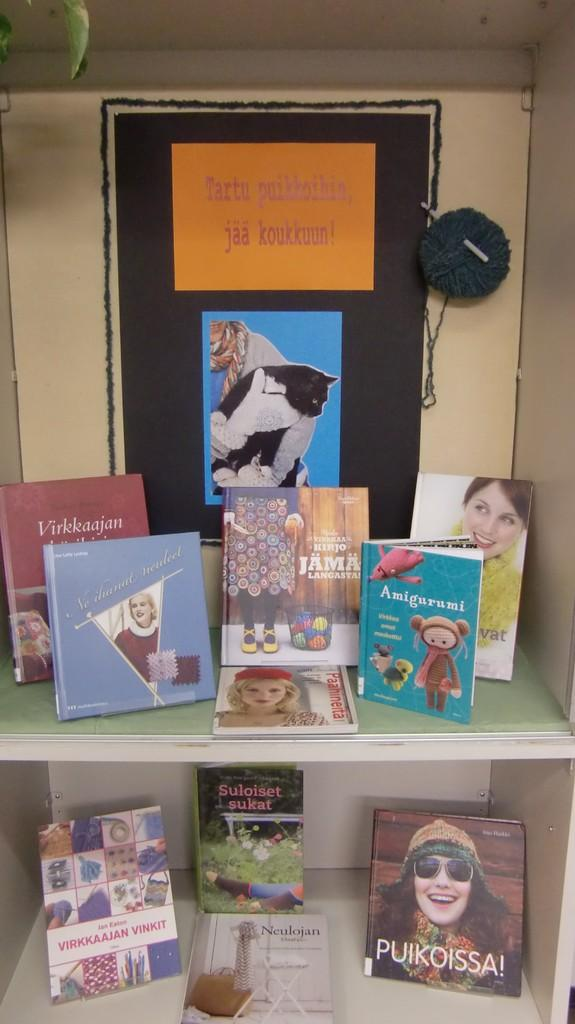<image>
Offer a succinct explanation of the picture presented. A display of books includes Puikoissa, Amigurumi, and Virkkaajan Vinkit. 